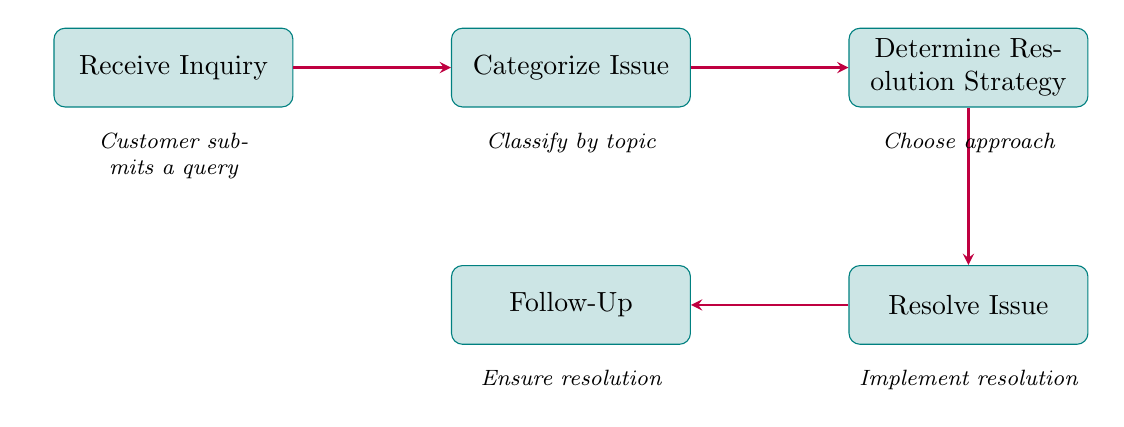What is the first step in the process? The diagram indicates that the first step is represented by the node "Receive Inquiry." Therefore, the beginning of the flow chart highlights this as the starting point of the customer inquiry resolution process.
Answer: Receive Inquiry How many nodes are there in the diagram? By counting each step labeled in the diagram, we identify five distinct nodes involved in the process: Receive Inquiry, Categorize Issue, Determine Resolution Strategy, Resolve Issue, and Follow-Up. Thus, the total count is five nodes.
Answer: 5 What comes after "Categorize Issue"? According to the flow indicated by the arrows in the diagram, the node that follows "Categorize Issue" is "Determine Resolution Strategy." This shows the next step to be taken after categorization.
Answer: Determine Resolution Strategy What action is taken during "Resolve Issue"? The node "Resolve Issue" suggests that a resolution is then implemented based on strategies chosen earlier. This involves sending solutions or possibly forwarding the case to a specialist as shown in the description beneath the node.
Answer: Implement chosen resolution What is the purpose of the "Follow-Up" step? The role of "Follow-Up" is to ensure that the issue has been resolved satisfactorily from the customer's perspective. This includes confirming with the customer, conducting a satisfaction survey, or reopening the issue if not resolved properly.
Answer: Ensure resolution How does "Determine Resolution Strategy" connect to "Resolve Issue"? The arrow drawn from "Determine Resolution Strategy" directly leads to "Resolve Issue," indicating a sequential flow where the strategy chosen dictates the action performed in the next step. This relationship shows an essential step in resolving the customer's inquiry.
Answer: Direct connection through an arrow What types of inquiries can be categorized under "Categorize Issue"? The "Categorize Issue" node allows for classification by three primary topics: Billing, Technical Support, and General Info. This categorization helps determine the nature of the customer’s concern.
Answer: Billing, Technical Support, General Info Which step involves customer interaction after the resolution? The "Follow-Up" step explicitly mentions interacting with the customer to confirm satisfactory resolution and gather feedback. This highlights engagement with the customer after the issues have been addressed.
Answer: Follow-Up What is the last step in the inquiry resolution process? The last step, according to the flow of the diagram, is "Follow-Up," completing the customer inquiry resolution process to ensure all issues are satisfactorily addressed.
Answer: Follow-Up 